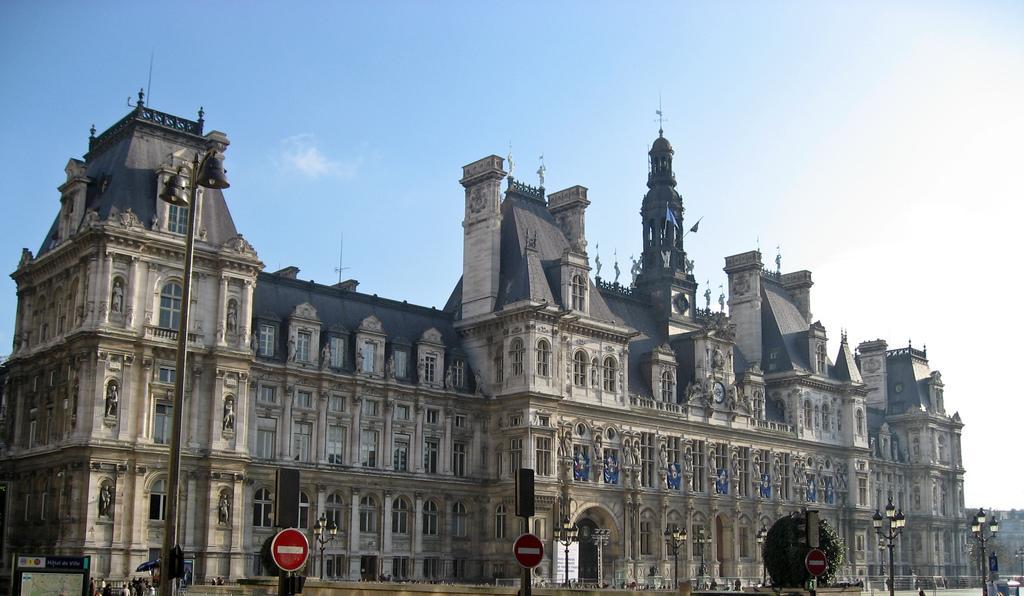How would you summarize this image in a sentence or two? This picture consists of hotel de ville in the image, there are many windows on it, there are people at the bottom side of the image and there are lamp and traffic poles in the image and there is a plant in the image. 